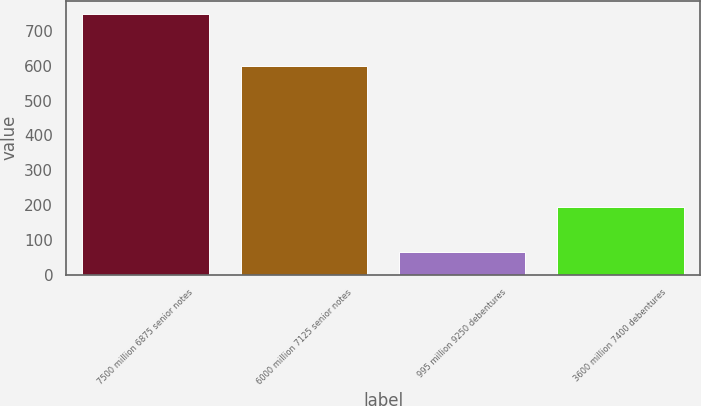<chart> <loc_0><loc_0><loc_500><loc_500><bar_chart><fcel>7500 million 6875 senior notes<fcel>6000 million 7125 senior notes<fcel>995 million 9250 debentures<fcel>3600 million 7400 debentures<nl><fcel>750<fcel>600<fcel>64.2<fcel>194.8<nl></chart> 